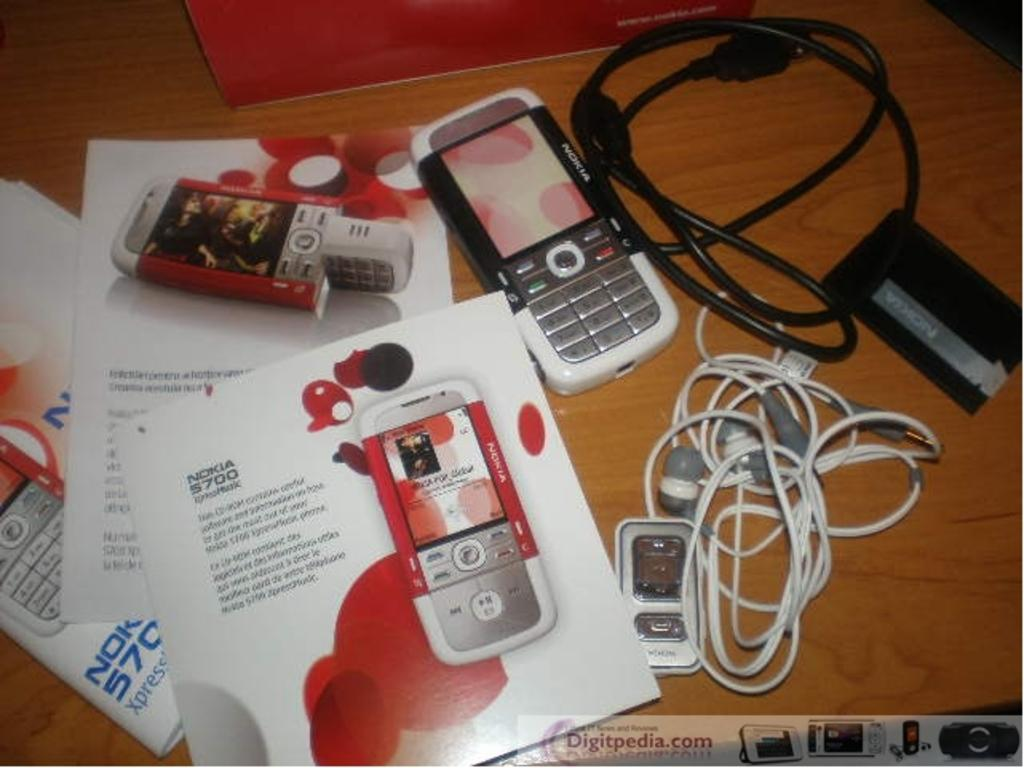<image>
Relay a brief, clear account of the picture shown. two small Nokia phone on a table with ear phones and operating manuals 